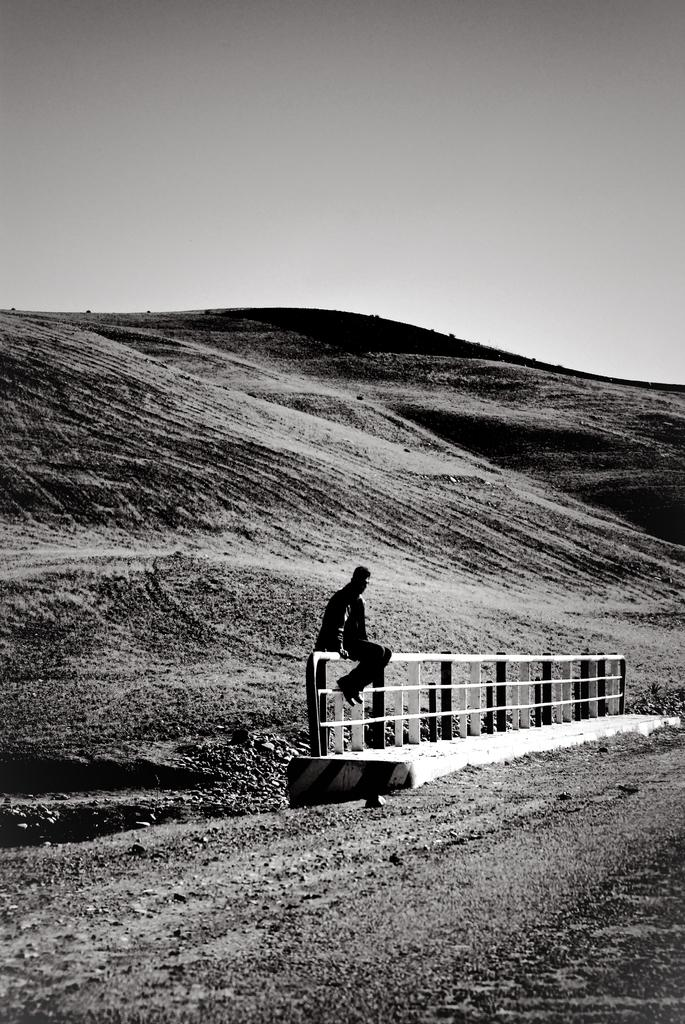Who is present in the image? There is a person in the image. What is the person wearing? The person is wearing a black dress. What is the person doing in the image? The person is sitting on a fence. What can be seen in the distance in the image? There is a mountain visible in the background of the image. What type of desk is the stranger using in the image? There is no stranger or desk present in the image; it features a person sitting on a fence with a mountain in the background. 